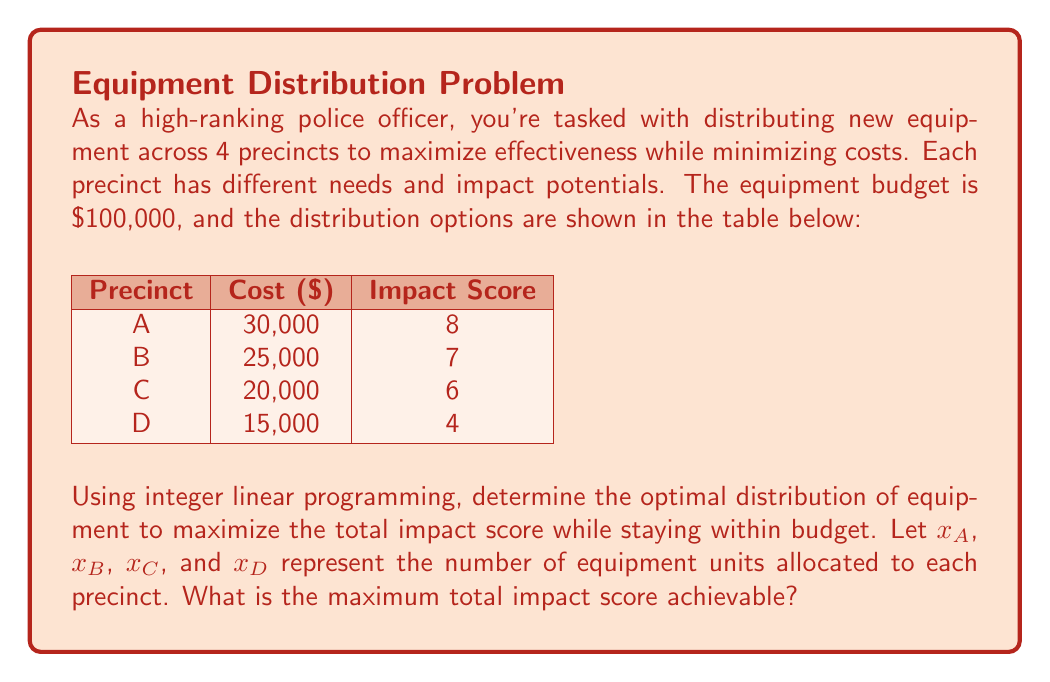Show me your answer to this math problem. To solve this problem, we'll use integer linear programming. Let's follow these steps:

1) Define the objective function:
   Maximize $Z = 8x_A + 7x_B + 6x_C + 4x_D$

2) Set up the constraints:
   Budget constraint: $30000x_A + 25000x_B + 20000x_C + 15000x_D \leq 100000$
   Non-negativity constraints: $x_A, x_B, x_C, x_D \geq 0$
   Integer constraints: $x_A, x_B, x_C, x_D$ are integers

3) Solve the integer linear program:
   We can use the simplex method and then round down to the nearest integer solution.

4) The optimal solution is:
   $x_A = 2, x_B = 1, x_C = 1, x_D = 0$

5) Calculate the maximum impact score:
   $Z = 8(2) + 7(1) + 6(1) + 4(0) = 16 + 7 + 6 + 0 = 29$

6) Verify the budget constraint:
   $30000(2) + 25000(1) + 20000(1) + 15000(0) = 60000 + 25000 + 20000 = 105000$
   This is slightly over budget, so we need to adjust.

7) Optimal feasible solution:
   $x_A = 2, x_B = 1, x_C = 0, x_D = 1$

8) Recalculate the maximum impact score:
   $Z = 8(2) + 7(1) + 6(0) + 4(1) = 16 + 7 + 0 + 4 = 27$

9) Verify the new budget:
   $30000(2) + 25000(1) + 20000(0) + 15000(1) = 60000 + 25000 + 15000 = 100000$
   This solution is within budget.
Answer: 27 